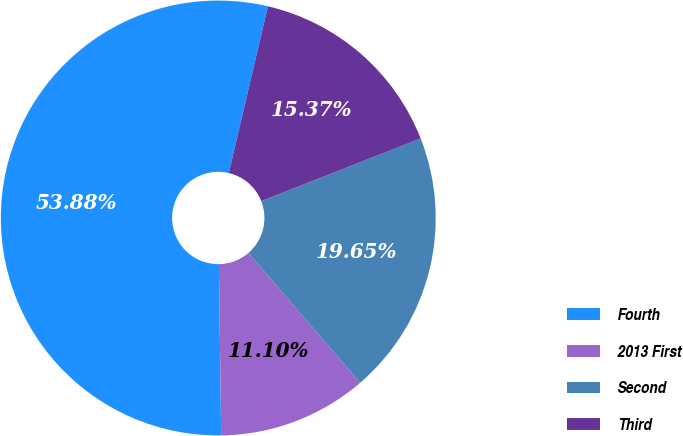Convert chart to OTSL. <chart><loc_0><loc_0><loc_500><loc_500><pie_chart><fcel>Fourth<fcel>2013 First<fcel>Second<fcel>Third<nl><fcel>53.88%<fcel>11.1%<fcel>19.65%<fcel>15.37%<nl></chart> 